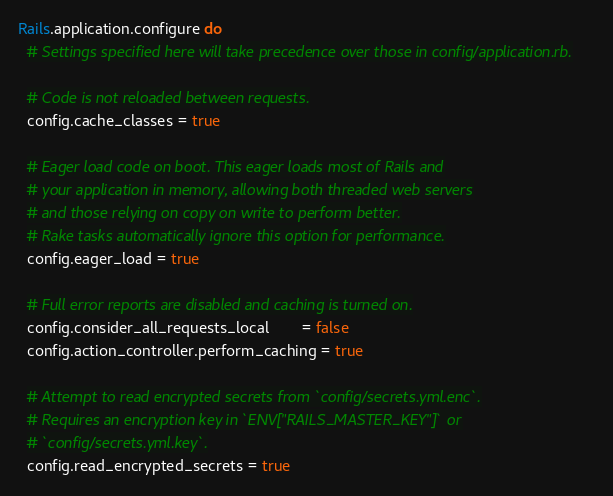Convert code to text. <code><loc_0><loc_0><loc_500><loc_500><_Ruby_>Rails.application.configure do
  # Settings specified here will take precedence over those in config/application.rb.

  # Code is not reloaded between requests.
  config.cache_classes = true

  # Eager load code on boot. This eager loads most of Rails and
  # your application in memory, allowing both threaded web servers
  # and those relying on copy on write to perform better.
  # Rake tasks automatically ignore this option for performance.
  config.eager_load = true

  # Full error reports are disabled and caching is turned on.
  config.consider_all_requests_local       = false
  config.action_controller.perform_caching = true

  # Attempt to read encrypted secrets from `config/secrets.yml.enc`.
  # Requires an encryption key in `ENV["RAILS_MASTER_KEY"]` or
  # `config/secrets.yml.key`.
  config.read_encrypted_secrets = true
</code> 